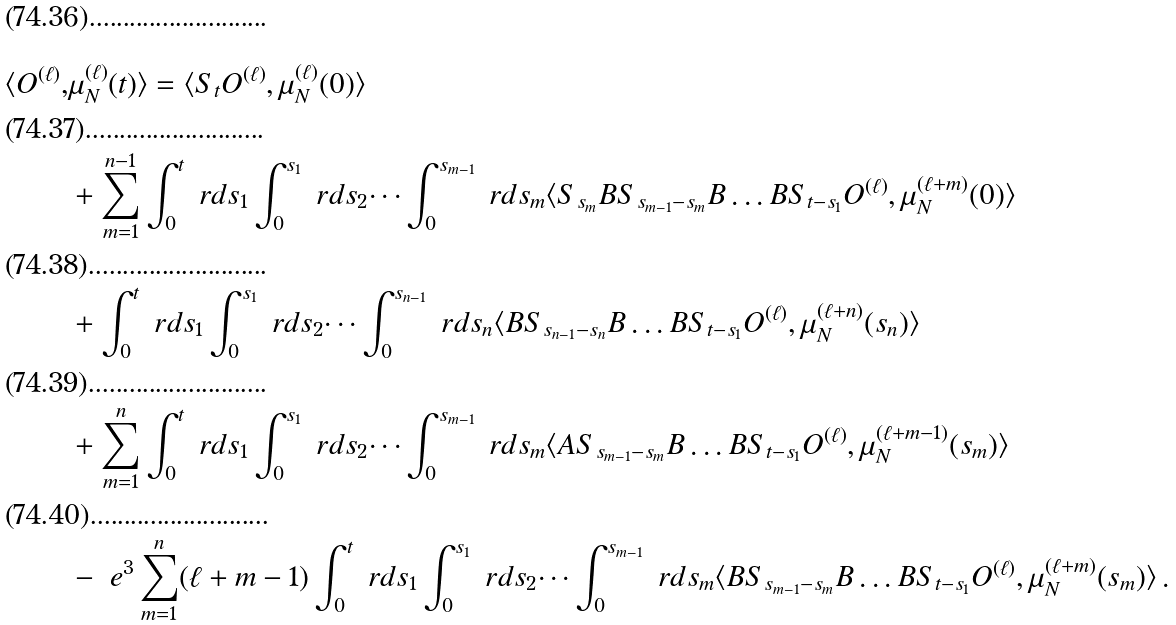<formula> <loc_0><loc_0><loc_500><loc_500>\langle O ^ { ( \ell ) } , & \mu _ { N } ^ { ( \ell ) } ( t ) \rangle = \langle S _ { t } O ^ { ( \ell ) } , \mu _ { N } ^ { ( \ell ) } ( 0 ) \rangle \\ & + \sum _ { m = 1 } ^ { n - 1 } \int _ { 0 } ^ { t } \ r d s _ { 1 } \int _ { 0 } ^ { s _ { 1 } } \ r d s _ { 2 } \dots \int _ { 0 } ^ { s _ { m - 1 } } \ r d s _ { m } \langle S _ { s _ { m } } B S _ { s _ { m - 1 } - s _ { m } } B \dots B S _ { t - s _ { 1 } } O ^ { ( \ell ) } , \mu _ { N } ^ { ( \ell + m ) } ( 0 ) \rangle \\ & + \int _ { 0 } ^ { t } \ r d s _ { 1 } \int _ { 0 } ^ { s _ { 1 } } \ r d s _ { 2 } \dots \int _ { 0 } ^ { s _ { n - 1 } } \ r d s _ { n } \langle B S _ { s _ { n - 1 } - s _ { n } } B \dots B S _ { t - s _ { 1 } } O ^ { ( \ell ) } , \mu _ { N } ^ { ( \ell + n ) } ( s _ { n } ) \rangle \\ & + \sum _ { m = 1 } ^ { n } \int _ { 0 } ^ { t } \ r d s _ { 1 } \int _ { 0 } ^ { s _ { 1 } } \ r d s _ { 2 } \dots \int _ { 0 } ^ { s _ { m - 1 } } \ r d s _ { m } \langle A S _ { s _ { m - 1 } - s _ { m } } B \dots B S _ { t - s _ { 1 } } O ^ { ( \ell ) } , \mu _ { N } ^ { ( \ell + m - 1 ) } ( s _ { m } ) \rangle \\ & - \ e ^ { 3 } \sum _ { m = 1 } ^ { n } ( \ell + m - 1 ) \int _ { 0 } ^ { t } \ r d s _ { 1 } \int _ { 0 } ^ { s _ { 1 } } \ r d s _ { 2 } \dots \int _ { 0 } ^ { s _ { m - 1 } } \ r d s _ { m } \langle B S _ { s _ { m - 1 } - s _ { m } } B \dots B S _ { t - s _ { 1 } } O ^ { ( \ell ) } , \mu _ { N } ^ { ( \ell + m ) } ( s _ { m } ) \rangle \, .</formula> 